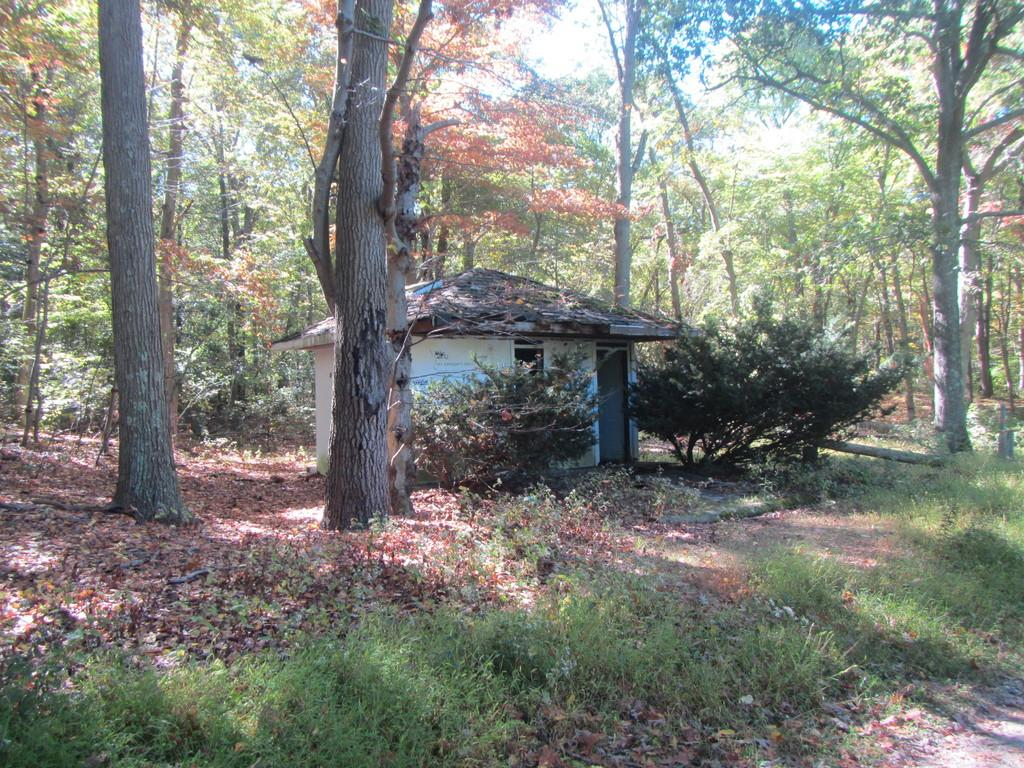What type of structure is present in the image? There is a house in the image. What type of vegetation can be seen in the image? There is grass visible in the image. What can be seen in the background of the image? There are trees in the background of the image. What type of toothpaste is being used to clean the oven in the image? There is no oven or toothpaste present in the image. 